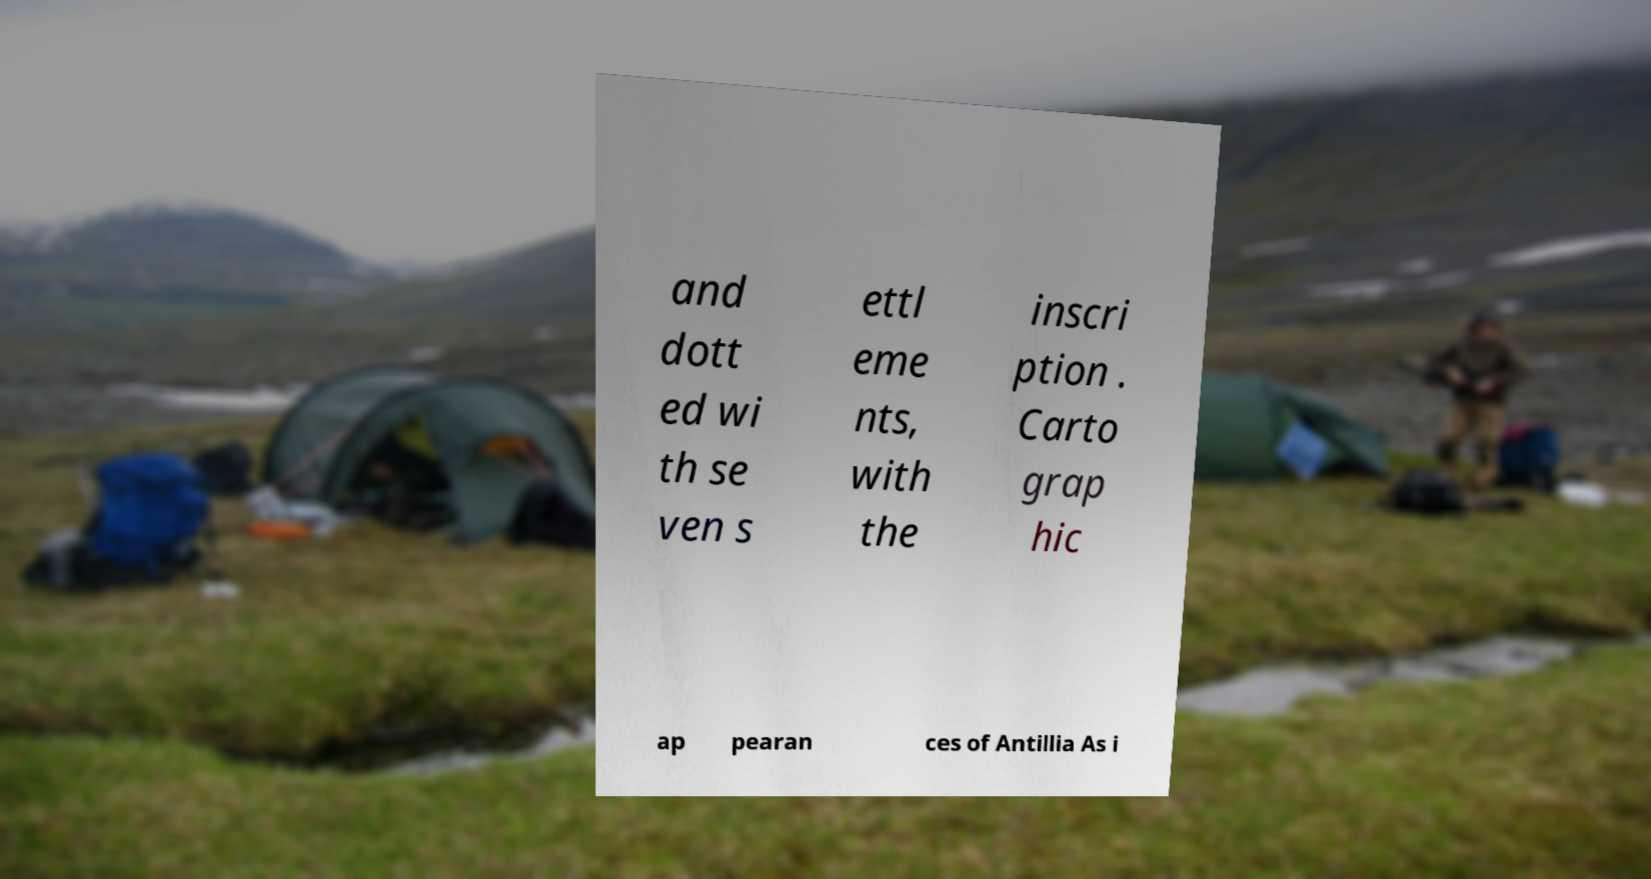I need the written content from this picture converted into text. Can you do that? and dott ed wi th se ven s ettl eme nts, with the inscri ption . Carto grap hic ap pearan ces of Antillia As i 